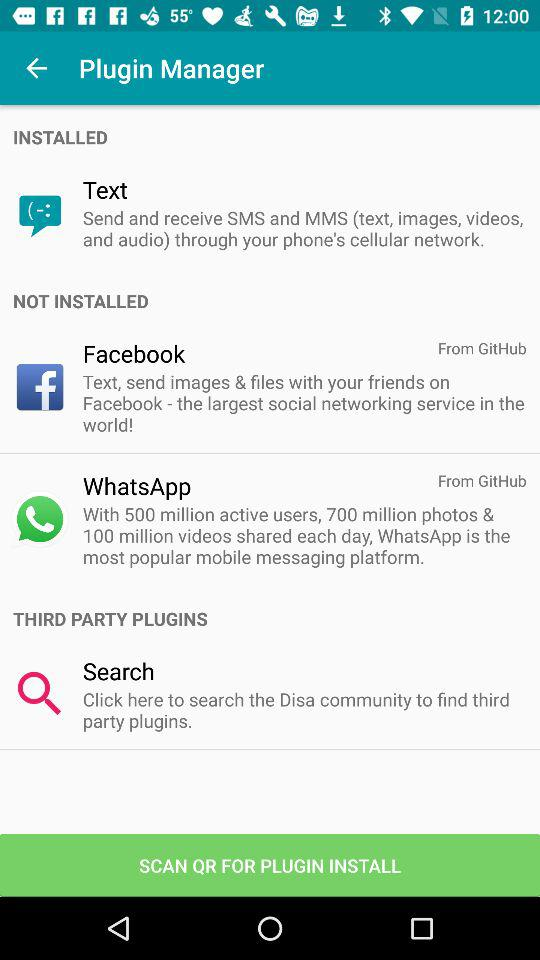What is the installed plugin name? The installed plugin name is "Text". 